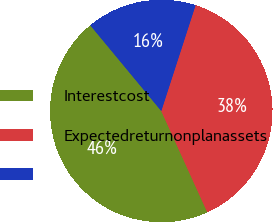Convert chart. <chart><loc_0><loc_0><loc_500><loc_500><pie_chart><fcel>Interestcost<fcel>Expectedreturnonplanassets<fcel>Unnamed: 2<nl><fcel>45.78%<fcel>38.22%<fcel>16.0%<nl></chart> 